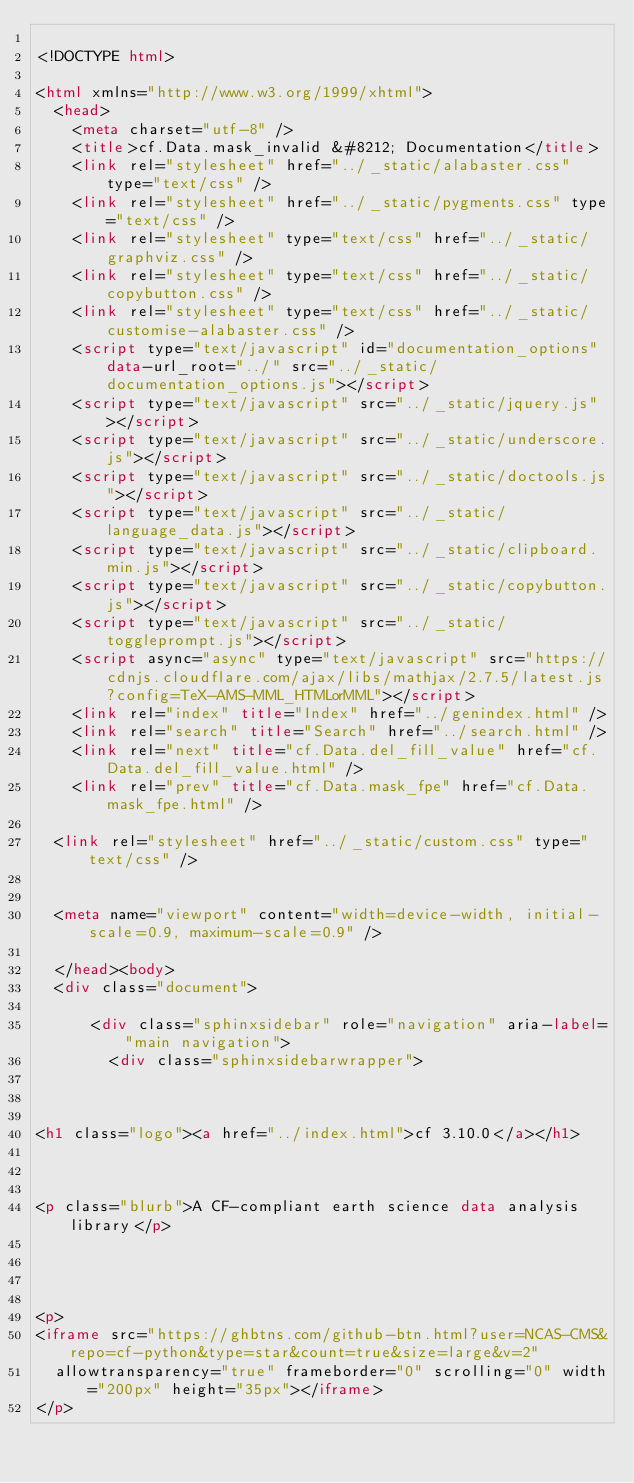Convert code to text. <code><loc_0><loc_0><loc_500><loc_500><_HTML_>
<!DOCTYPE html>

<html xmlns="http://www.w3.org/1999/xhtml">
  <head>
    <meta charset="utf-8" />
    <title>cf.Data.mask_invalid &#8212; Documentation</title>
    <link rel="stylesheet" href="../_static/alabaster.css" type="text/css" />
    <link rel="stylesheet" href="../_static/pygments.css" type="text/css" />
    <link rel="stylesheet" type="text/css" href="../_static/graphviz.css" />
    <link rel="stylesheet" type="text/css" href="../_static/copybutton.css" />
    <link rel="stylesheet" type="text/css" href="../_static/customise-alabaster.css" />
    <script type="text/javascript" id="documentation_options" data-url_root="../" src="../_static/documentation_options.js"></script>
    <script type="text/javascript" src="../_static/jquery.js"></script>
    <script type="text/javascript" src="../_static/underscore.js"></script>
    <script type="text/javascript" src="../_static/doctools.js"></script>
    <script type="text/javascript" src="../_static/language_data.js"></script>
    <script type="text/javascript" src="../_static/clipboard.min.js"></script>
    <script type="text/javascript" src="../_static/copybutton.js"></script>
    <script type="text/javascript" src="../_static/toggleprompt.js"></script>
    <script async="async" type="text/javascript" src="https://cdnjs.cloudflare.com/ajax/libs/mathjax/2.7.5/latest.js?config=TeX-AMS-MML_HTMLorMML"></script>
    <link rel="index" title="Index" href="../genindex.html" />
    <link rel="search" title="Search" href="../search.html" />
    <link rel="next" title="cf.Data.del_fill_value" href="cf.Data.del_fill_value.html" />
    <link rel="prev" title="cf.Data.mask_fpe" href="cf.Data.mask_fpe.html" />
   
  <link rel="stylesheet" href="../_static/custom.css" type="text/css" />
  
  
  <meta name="viewport" content="width=device-width, initial-scale=0.9, maximum-scale=0.9" />

  </head><body>
  <div class="document">
    
      <div class="sphinxsidebar" role="navigation" aria-label="main navigation">
        <div class="sphinxsidebarwrapper">



<h1 class="logo"><a href="../index.html">cf 3.10.0</a></h1>



<p class="blurb">A CF-compliant earth science data analysis library</p>




<p>
<iframe src="https://ghbtns.com/github-btn.html?user=NCAS-CMS&repo=cf-python&type=star&count=true&size=large&v=2"
  allowtransparency="true" frameborder="0" scrolling="0" width="200px" height="35px"></iframe>
</p>





</code> 